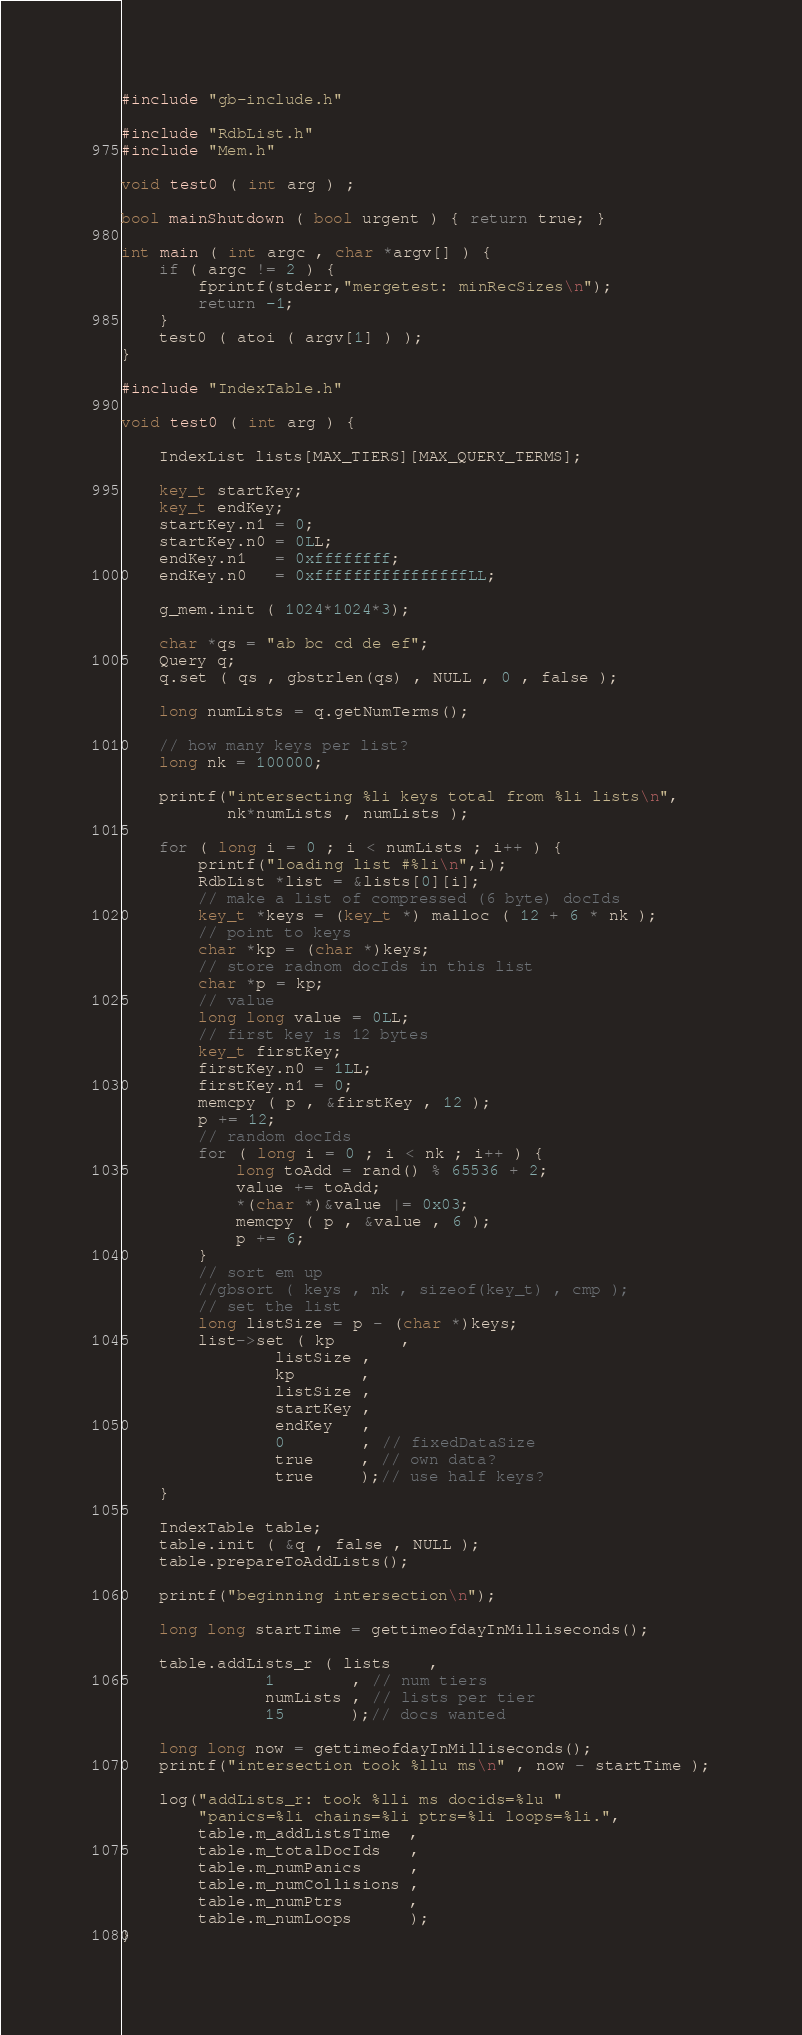<code> <loc_0><loc_0><loc_500><loc_500><_C++_>#include "gb-include.h"

#include "RdbList.h"
#include "Mem.h"

void test0 ( int arg ) ;

bool mainShutdown ( bool urgent ) { return true; }

int main ( int argc , char *argv[] ) {
	if ( argc != 2 ) {
		fprintf(stderr,"mergetest: minRecSizes\n");
		return -1;
	}
	test0 ( atoi ( argv[1] ) );
}

#include "IndexTable.h"

void test0 ( int arg ) {

	IndexList lists[MAX_TIERS][MAX_QUERY_TERMS];

	key_t startKey;
	key_t endKey;
	startKey.n1 = 0;
	startKey.n0 = 0LL;
	endKey.n1   = 0xffffffff;
	endKey.n0   = 0xffffffffffffffffLL;

	g_mem.init ( 1024*1024*3);

	char *qs = "ab bc cd de ef";
	Query q;
	q.set ( qs , gbstrlen(qs) , NULL , 0 , false );

	long numLists = q.getNumTerms();

	// how many keys per list?
	long nk = 100000;

	printf("intersecting %li keys total from %li lists\n", 
	       nk*numLists , numLists );

	for ( long i = 0 ; i < numLists ; i++ ) {
		printf("loading list #%li\n",i);
		RdbList *list = &lists[0][i]; 
		// make a list of compressed (6 byte) docIds
		key_t *keys = (key_t *) malloc ( 12 + 6 * nk );
		// point to keys
		char *kp = (char *)keys;
		// store radnom docIds in this list
		char *p = kp;
		// value
		long long value = 0LL;
		// first key is 12 bytes
		key_t firstKey;
		firstKey.n0 = 1LL;
		firstKey.n1 = 0;
		memcpy ( p , &firstKey , 12 );
		p += 12;
		// random docIds
		for ( long i = 0 ; i < nk ; i++ ) {
			long toAdd = rand() % 65536 + 2;
			value += toAdd;
			*(char *)&value |= 0x03;
			memcpy ( p , &value , 6 );
			p += 6;
		}
		// sort em up
		//gbsort ( keys , nk , sizeof(key_t) , cmp );
		// set the list
		long listSize = p - (char *)keys;
		list->set ( kp       ,
			    listSize ,
			    kp       ,
			    listSize ,
			    startKey ,
			    endKey   ,
			    0        , // fixedDataSize
			    true     , // own data?
			    true     );// use half keys?
	}

	IndexTable table;
	table.init ( &q , false , NULL );
	table.prepareToAddLists();

	printf("beginning intersection\n");

	long long startTime = gettimeofdayInMilliseconds();

	table.addLists_r ( lists    ,
			   1        , // num tiers
			   numLists , // lists per tier
			   15       );// docs wanted

	long long now = gettimeofdayInMilliseconds();
	printf("intersection took %llu ms\n" , now - startTime );

	log("addLists_r: took %lli ms docids=%lu "
	    "panics=%li chains=%li ptrs=%li loops=%li.",
	    table.m_addListsTime  ,
	    table.m_totalDocIds   ,
	    table.m_numPanics     ,
	    table.m_numCollisions ,
	    table.m_numPtrs       ,
	    table.m_numLoops      );
}
</code> 